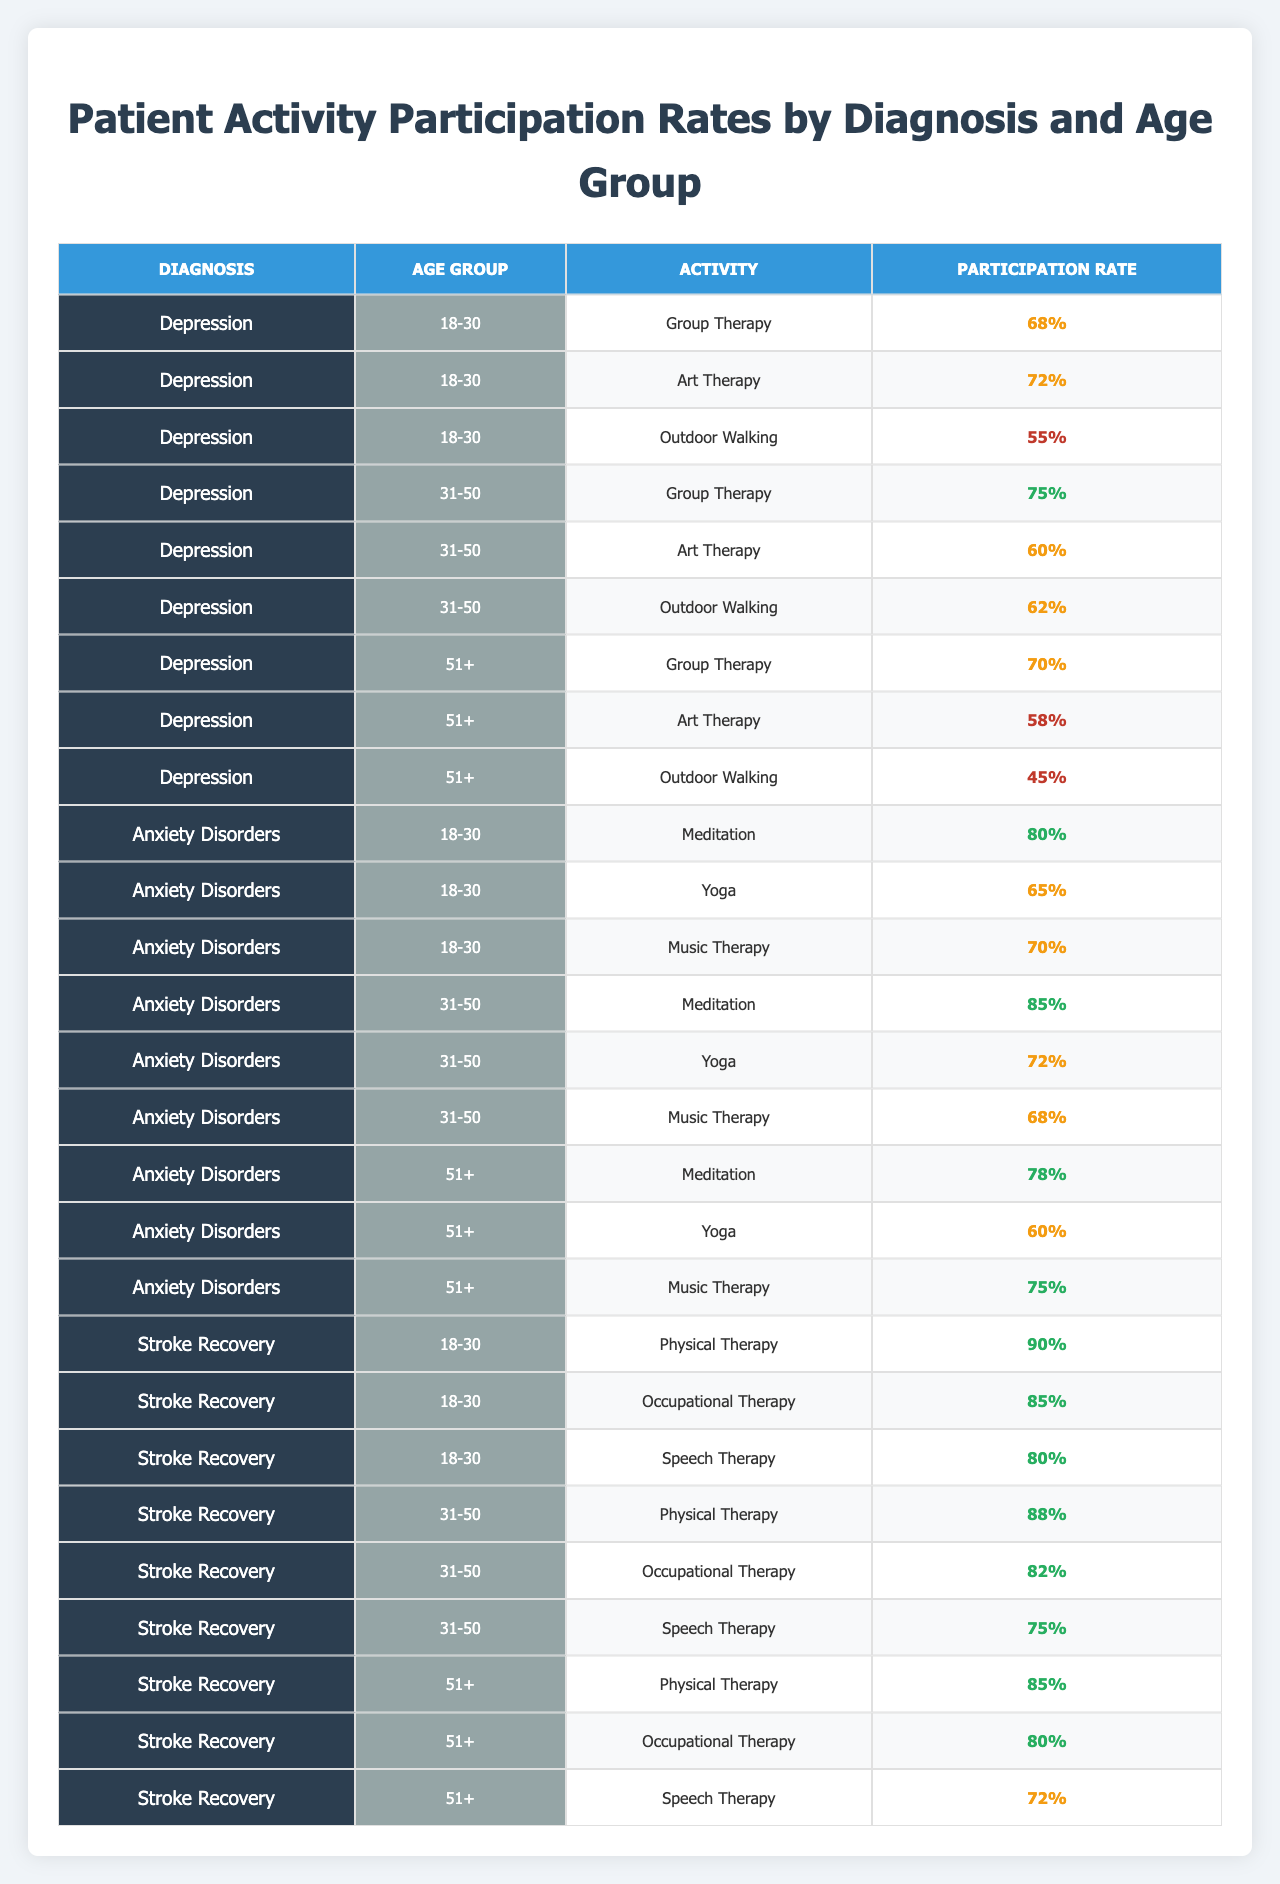What is the participation rate for Group Therapy in the age group 31-50 under Depression? According to the table, the participation rate for Group Therapy in the age group 31-50 is listed as 75%.
Answer: 75% What is the highest participation rate for any activity among patients with Anxiety Disorders aged 18-30? From the table, the participation rates for Anxiety Disorders aged 18-30 are Meditation (80%), Yoga (65%), and Music Therapy (70%). The highest is 80%.
Answer: 80% Which activity has the lowest participation rate for patients aged 51 and older with Depression? The activities for Depression aged 51+ are Group Therapy (70%), Art Therapy (58%), and Outdoor Walking (45%). The lowest participation rate is Outdoor Walking at 45%.
Answer: 45% Is Meditation a more popular activity than Yoga among patients aged 31-50 with Anxiety Disorders? For patients aged 31-50 with Anxiety Disorders, the participation rates are Meditation (85%) and Yoga (72%). Since 85% is greater than 72%, Meditation is more popular than Yoga.
Answer: Yes What is the average participation rate for Physical Therapy across all age groups under Stroke Recovery? The participation rates for Physical Therapy are 90% (18-30), 88% (31-50), and 85% (51+). We calculate the average as (90 + 88 + 85) / 3 = 87.67%.
Answer: 87.67% Which diagnosis has the highest participation rate for Yoga among the age group 31-50? The Yoga participation rates for 31-50 age group are: Depression (60%), Anxiety Disorders (72%), and Stroke Recovery (not listed as it wasn't included). Here, Anxiety Disorders has the highest at 72%.
Answer: 72% Is there any activity under Stroke Recovery for the age group 51+ that has a participation rate below 75%? The participation rates for the 51+ age group under Stroke Recovery are Physical Therapy (85%), Occupational Therapy (80%), and Speech Therapy (72%). Speech Therapy is below 75%.
Answer: Yes How many activities have a participation rate of 60% or higher for patients aged 18-30 with Anxiety Disorders? The participation rates are Meditation (80%), Yoga (65%), and Music Therapy (70%). All three are 60% or above, giving a total of 3 activities.
Answer: 3 Which age group within Depression has the highest overall average participation rate across all activities? The participation rates are: 18-30: (68+72+55)/3 = 65%, 31-50: (75+60+62)/3 = 65.67%, and 51+: (70+58+45)/3 = 57.67%. The highest is for 31-50 at 65.67%.
Answer: 31-50 Do patients aged 51 and older with Anxiety Disorders participate more in Meditation or Music Therapy? The participation rates are Meditation (78%) and Music Therapy (75%). Since 78% is greater than 75%, they participate more in Meditation.
Answer: Meditation 